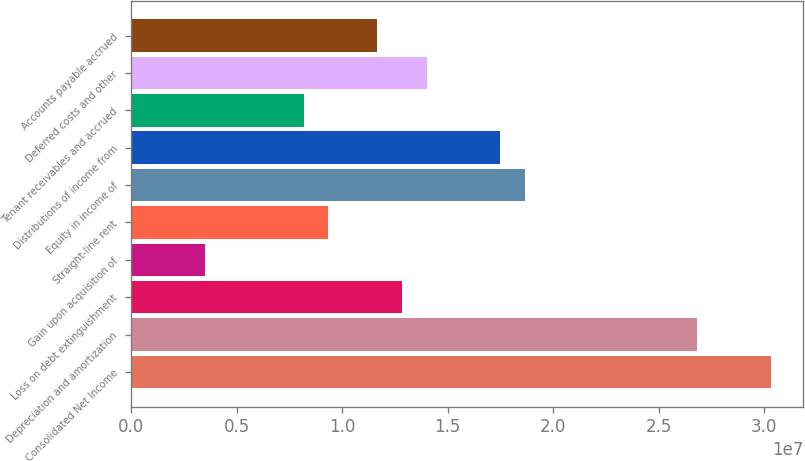Convert chart to OTSL. <chart><loc_0><loc_0><loc_500><loc_500><bar_chart><fcel>Consolidated Net Income<fcel>Depreciation and amortization<fcel>Loss on debt extinguishment<fcel>Gain upon acquisition of<fcel>Straight-line rent<fcel>Equity in income of<fcel>Distributions of income from<fcel>Tenant receivables and accrued<fcel>Deferred costs and other<fcel>Accounts payable accrued<nl><fcel>3.03363e+07<fcel>2.6836e+07<fcel>1.28348e+07<fcel>3.50064e+06<fcel>9.33449e+06<fcel>1.86686e+07<fcel>1.75019e+07<fcel>8.16772e+06<fcel>1.40016e+07<fcel>1.1668e+07<nl></chart> 